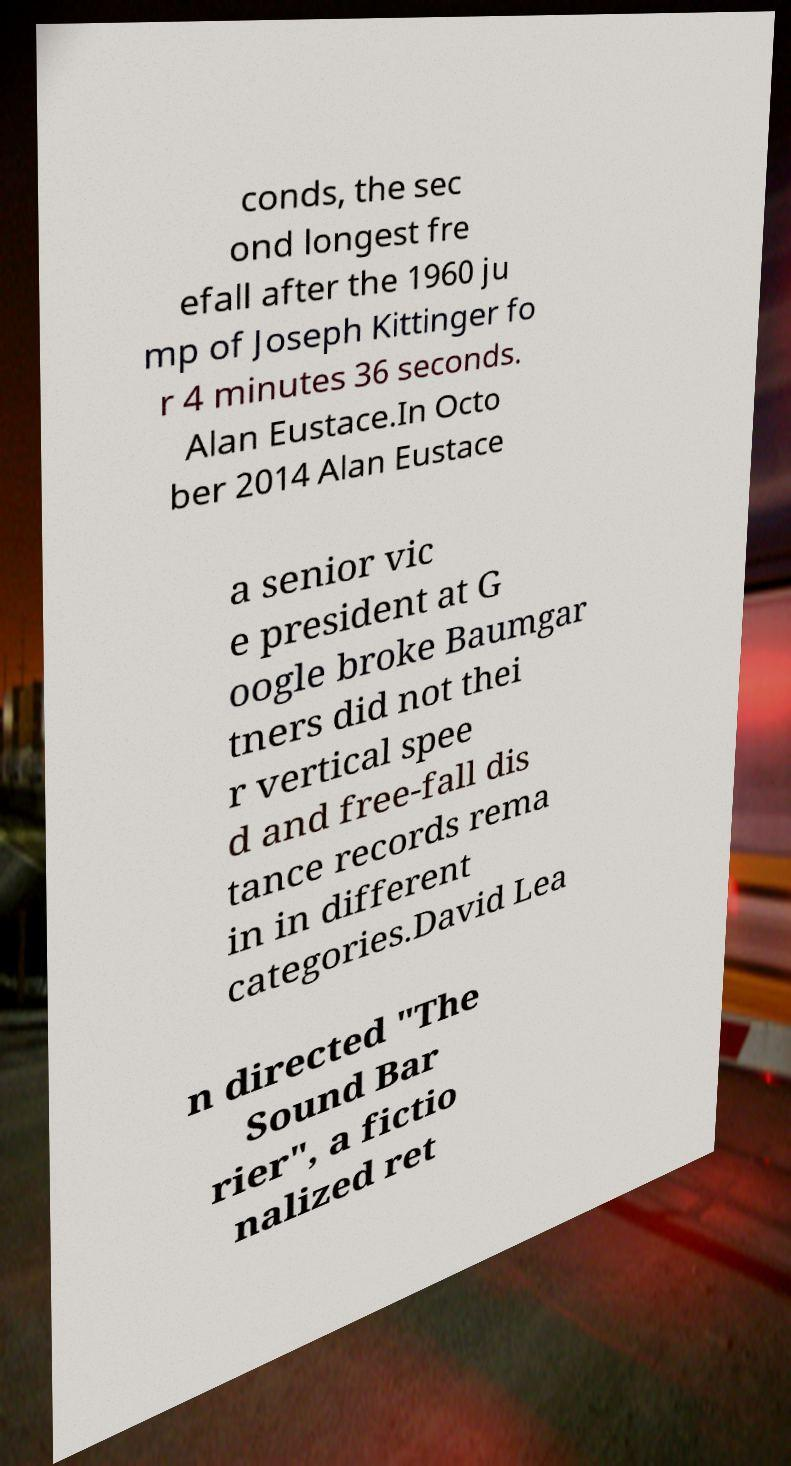Can you accurately transcribe the text from the provided image for me? conds, the sec ond longest fre efall after the 1960 ju mp of Joseph Kittinger fo r 4 minutes 36 seconds. Alan Eustace.In Octo ber 2014 Alan Eustace a senior vic e president at G oogle broke Baumgar tners did not thei r vertical spee d and free-fall dis tance records rema in in different categories.David Lea n directed "The Sound Bar rier", a fictio nalized ret 